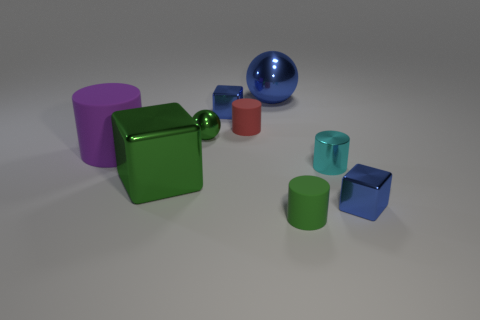Are there the same number of rubber objects that are to the left of the red rubber object and matte cylinders right of the small cyan thing?
Provide a succinct answer. No. What is the large blue sphere made of?
Offer a terse response. Metal. The metal sphere that is the same size as the green cylinder is what color?
Ensure brevity in your answer.  Green. There is a tiny blue block to the left of the blue ball; are there any metal spheres to the left of it?
Your answer should be compact. Yes. How many spheres are either cyan rubber things or big green things?
Make the answer very short. 0. What size is the cylinder that is left of the metallic cube that is on the left side of the small blue object behind the large green metallic cube?
Offer a very short reply. Large. Are there any big objects in front of the purple rubber object?
Offer a terse response. Yes. What is the shape of the small matte thing that is the same color as the large block?
Your answer should be compact. Cylinder. What number of things are small blue metallic blocks that are on the left side of the green rubber thing or blocks?
Your response must be concise. 3. There is a blue sphere that is made of the same material as the tiny cyan cylinder; what size is it?
Give a very brief answer. Large. 